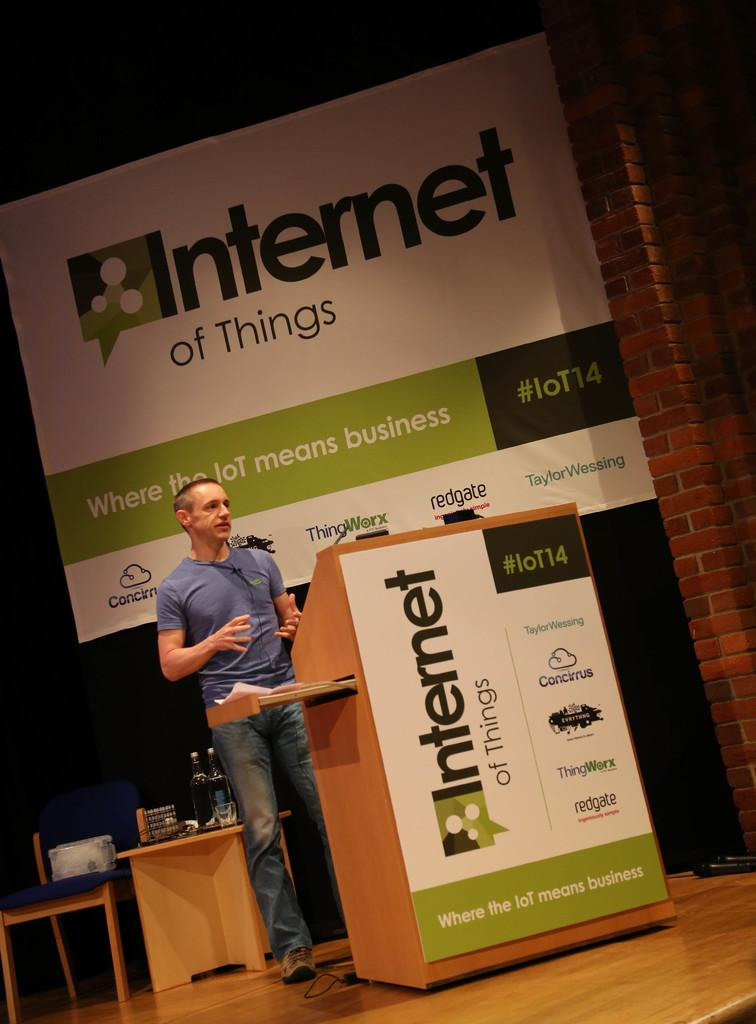What is the main subject of the image? There is a person standing in the image. Where is the person located in relation to other objects? The person is near a podium. What is close to the person in the image? There is a table near the person. What can be found on the table? There are different items on the table. How does the person plan to stitch the end of the rope in the image? There is no rope or stitching activity present in the image. 